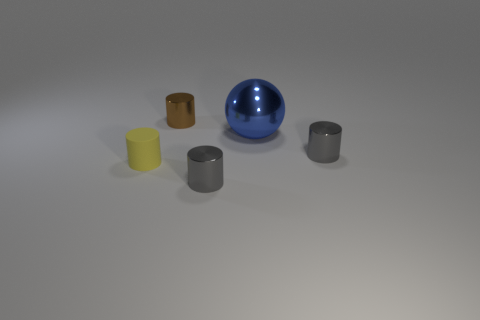Subtract all red balls. How many gray cylinders are left? 2 Subtract 1 cylinders. How many cylinders are left? 3 Subtract all brown metal cylinders. How many cylinders are left? 3 Add 4 large brown blocks. How many objects exist? 9 Subtract all brown cylinders. How many cylinders are left? 3 Add 3 small yellow objects. How many small yellow objects are left? 4 Add 1 metallic blocks. How many metallic blocks exist? 1 Subtract 0 gray balls. How many objects are left? 5 Subtract all cylinders. How many objects are left? 1 Subtract all red cylinders. Subtract all yellow blocks. How many cylinders are left? 4 